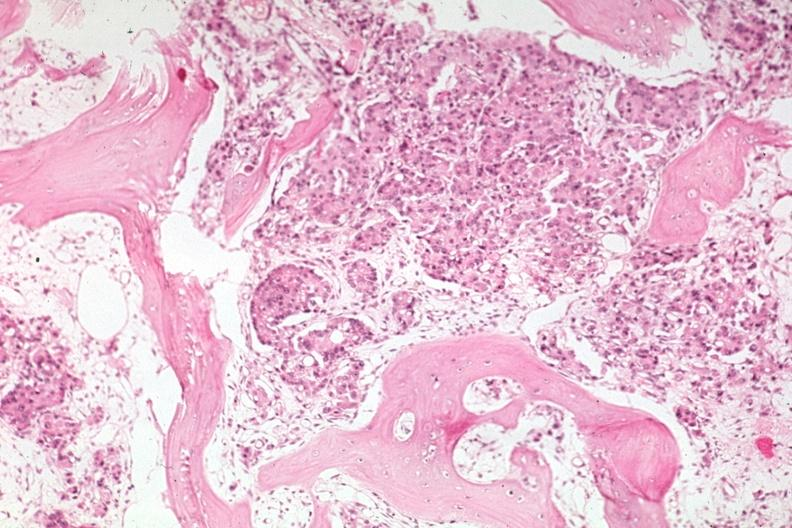how does this image show med good carcinoma?
Answer the question using a single word or phrase. With some bone resorption 